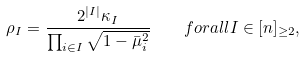<formula> <loc_0><loc_0><loc_500><loc_500>\rho _ { I } = \frac { 2 ^ { | I | } \kappa _ { I } } { \prod _ { i \in I } \sqrt { 1 - \bar { \mu } _ { i } ^ { 2 } } } \quad f o r a l l I \in [ n ] _ { \geq 2 } ,</formula> 